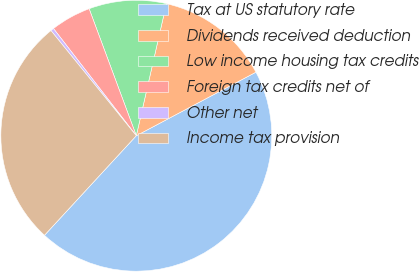Convert chart to OTSL. <chart><loc_0><loc_0><loc_500><loc_500><pie_chart><fcel>Tax at US statutory rate<fcel>Dividends received deduction<fcel>Low income housing tax credits<fcel>Foreign tax credits net of<fcel>Other net<fcel>Income tax provision<nl><fcel>44.63%<fcel>13.66%<fcel>9.23%<fcel>4.81%<fcel>0.38%<fcel>27.29%<nl></chart> 